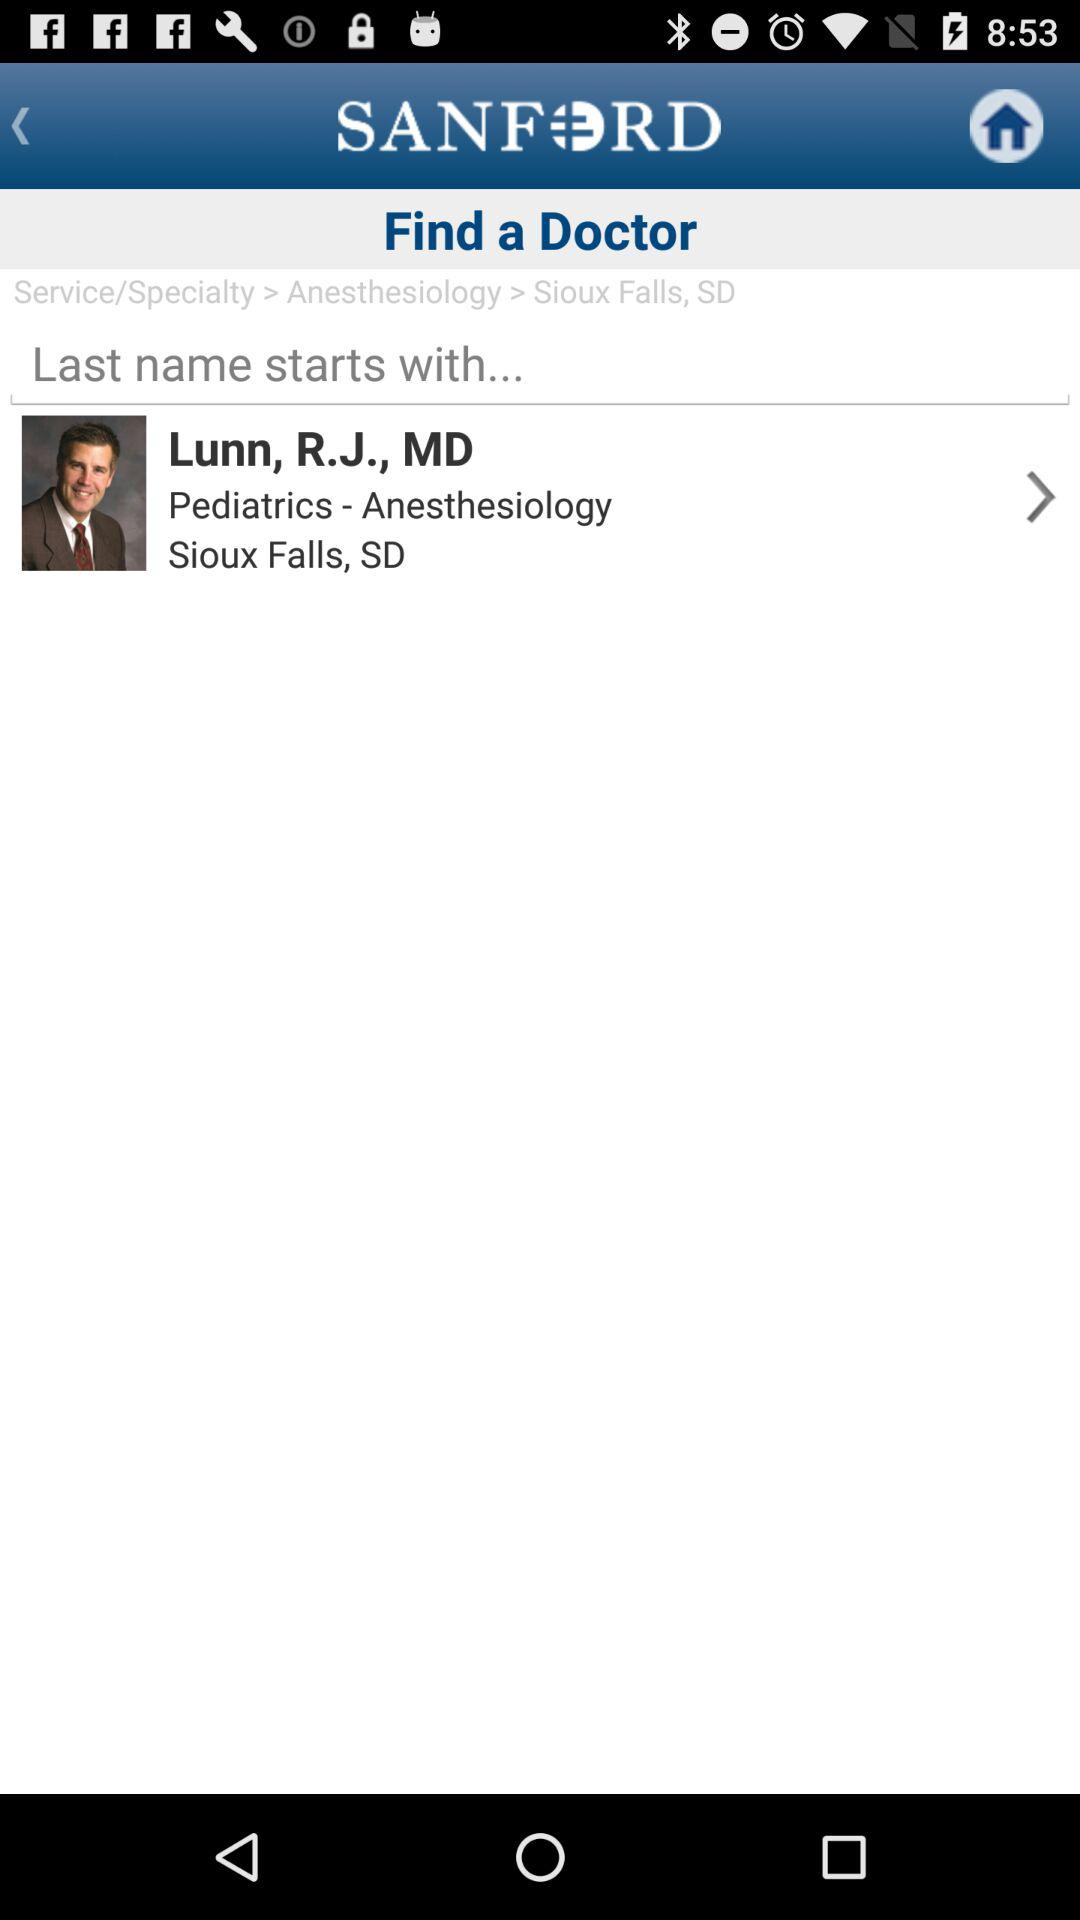What is the mentioned location? The mentioned location is Sioux Falls, SD. 